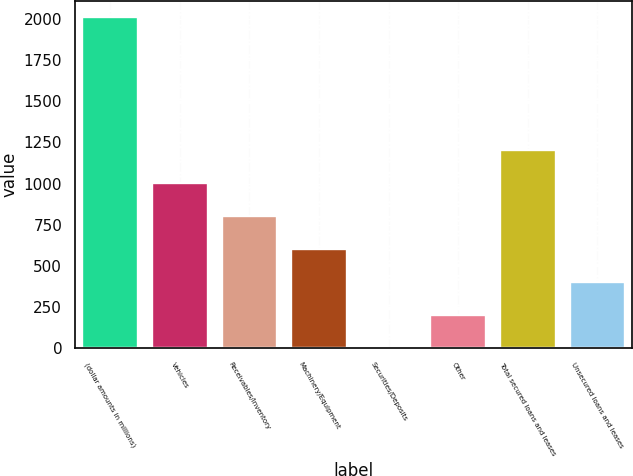Convert chart to OTSL. <chart><loc_0><loc_0><loc_500><loc_500><bar_chart><fcel>(dollar amounts in millions)<fcel>Vehicles<fcel>Receivables/Inventory<fcel>Machinery/Equipment<fcel>Securities/Deposits<fcel>Other<fcel>Total secured loans and leases<fcel>Unsecured loans and leases<nl><fcel>2010<fcel>1006<fcel>805.2<fcel>604.4<fcel>2<fcel>202.8<fcel>1206.8<fcel>403.6<nl></chart> 